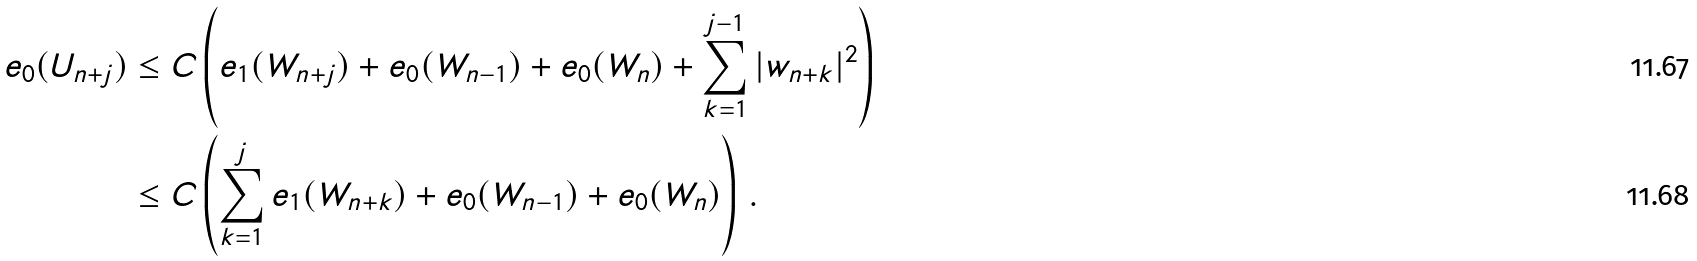Convert formula to latex. <formula><loc_0><loc_0><loc_500><loc_500>e _ { 0 } ( U _ { n + j } ) & \leq C \left ( e _ { 1 } ( W _ { n + j } ) + e _ { 0 } ( W _ { n - 1 } ) + e _ { 0 } ( W _ { n } ) + \sum _ { k = 1 } ^ { j - 1 } | w _ { n + k } | ^ { 2 } \right ) \\ & \leq C \left ( \sum _ { k = 1 } ^ { j } e _ { 1 } ( W _ { n + k } ) + e _ { 0 } ( W _ { n - 1 } ) + e _ { 0 } ( W _ { n } ) \right ) \, .</formula> 